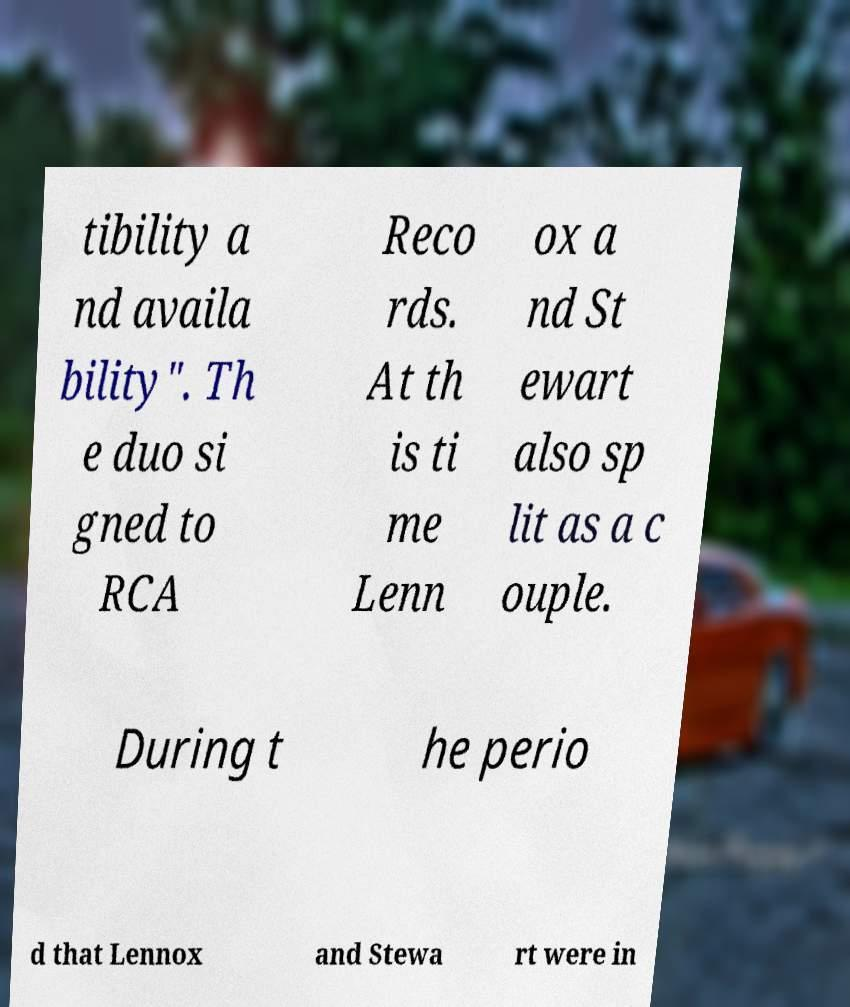For documentation purposes, I need the text within this image transcribed. Could you provide that? tibility a nd availa bility". Th e duo si gned to RCA Reco rds. At th is ti me Lenn ox a nd St ewart also sp lit as a c ouple. During t he perio d that Lennox and Stewa rt were in 